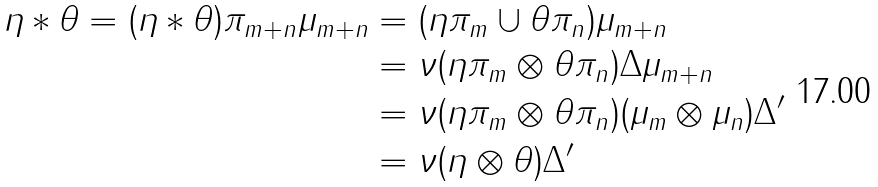<formula> <loc_0><loc_0><loc_500><loc_500>\eta \ast \theta = ( \eta \ast \theta ) \pi _ { m + n } \mu _ { m + n } & = ( \eta \pi _ { m } \cup \theta \pi _ { n } ) \mu _ { m + n } \\ & = \nu ( \eta \pi _ { m } \otimes \theta \pi _ { n } ) \Delta \mu _ { m + n } \\ & = \nu ( \eta \pi _ { m } \otimes \theta \pi _ { n } ) ( \mu _ { m } \otimes \mu _ { n } ) \Delta ^ { \prime } \\ & = \nu ( \eta \otimes \theta ) \Delta ^ { \prime }</formula> 